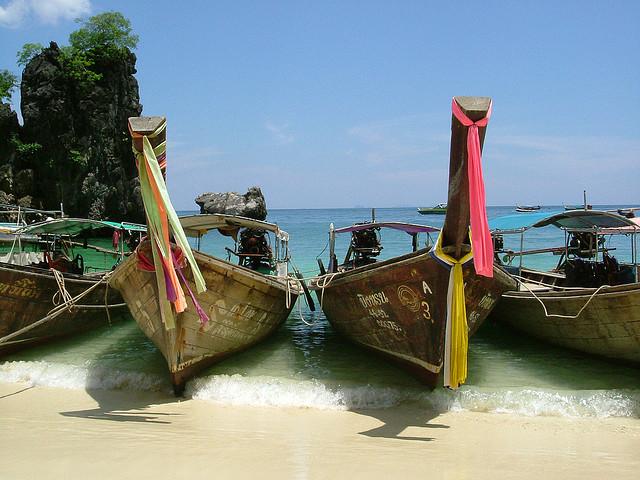What are the boats made from?
Quick response, please. Wood. What color are the two streamers on the boat to the right?
Short answer required. Red and yellow. Overcast or sunny?
Be succinct. Sunny. 